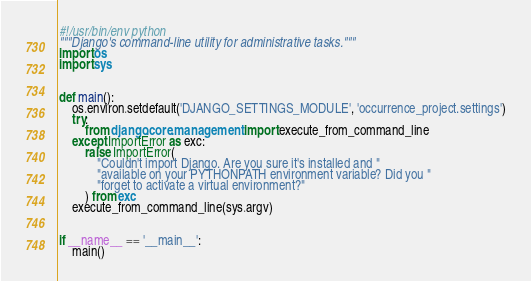Convert code to text. <code><loc_0><loc_0><loc_500><loc_500><_Python_>#!/usr/bin/env python
"""Django's command-line utility for administrative tasks."""
import os
import sys


def main():
    os.environ.setdefault('DJANGO_SETTINGS_MODULE', 'occurrence_project.settings')
    try:
        from django.core.management import execute_from_command_line
    except ImportError as exc:
        raise ImportError(
            "Couldn't import Django. Are you sure it's installed and "
            "available on your PYTHONPATH environment variable? Did you "
            "forget to activate a virtual environment?"
        ) from exc
    execute_from_command_line(sys.argv)


if __name__ == '__main__':
    main()
</code> 